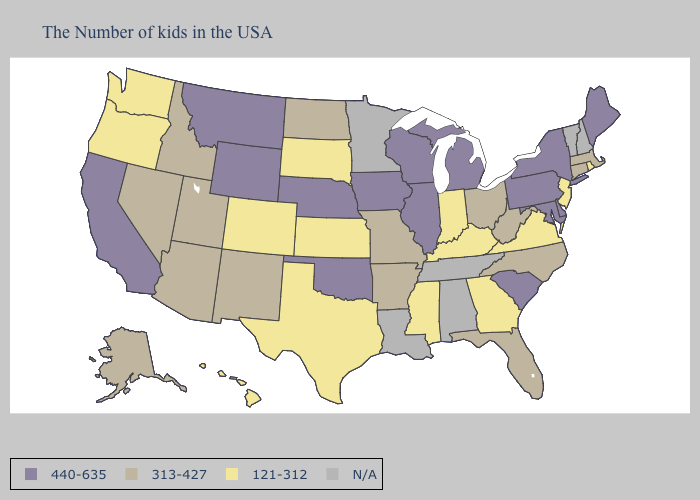What is the lowest value in the West?
Quick response, please. 121-312. Does North Dakota have the highest value in the USA?
Give a very brief answer. No. Name the states that have a value in the range N/A?
Short answer required. New Hampshire, Vermont, Alabama, Tennessee, Louisiana, Minnesota. What is the value of Wisconsin?
Give a very brief answer. 440-635. Among the states that border Michigan , which have the lowest value?
Short answer required. Indiana. Which states hav the highest value in the South?
Keep it brief. Delaware, Maryland, South Carolina, Oklahoma. Does Texas have the lowest value in the USA?
Concise answer only. Yes. What is the lowest value in the USA?
Keep it brief. 121-312. Is the legend a continuous bar?
Answer briefly. No. How many symbols are there in the legend?
Short answer required. 4. What is the highest value in states that border New York?
Give a very brief answer. 440-635. What is the lowest value in states that border Georgia?
Keep it brief. 313-427. How many symbols are there in the legend?
Write a very short answer. 4. What is the value of Illinois?
Write a very short answer. 440-635. 